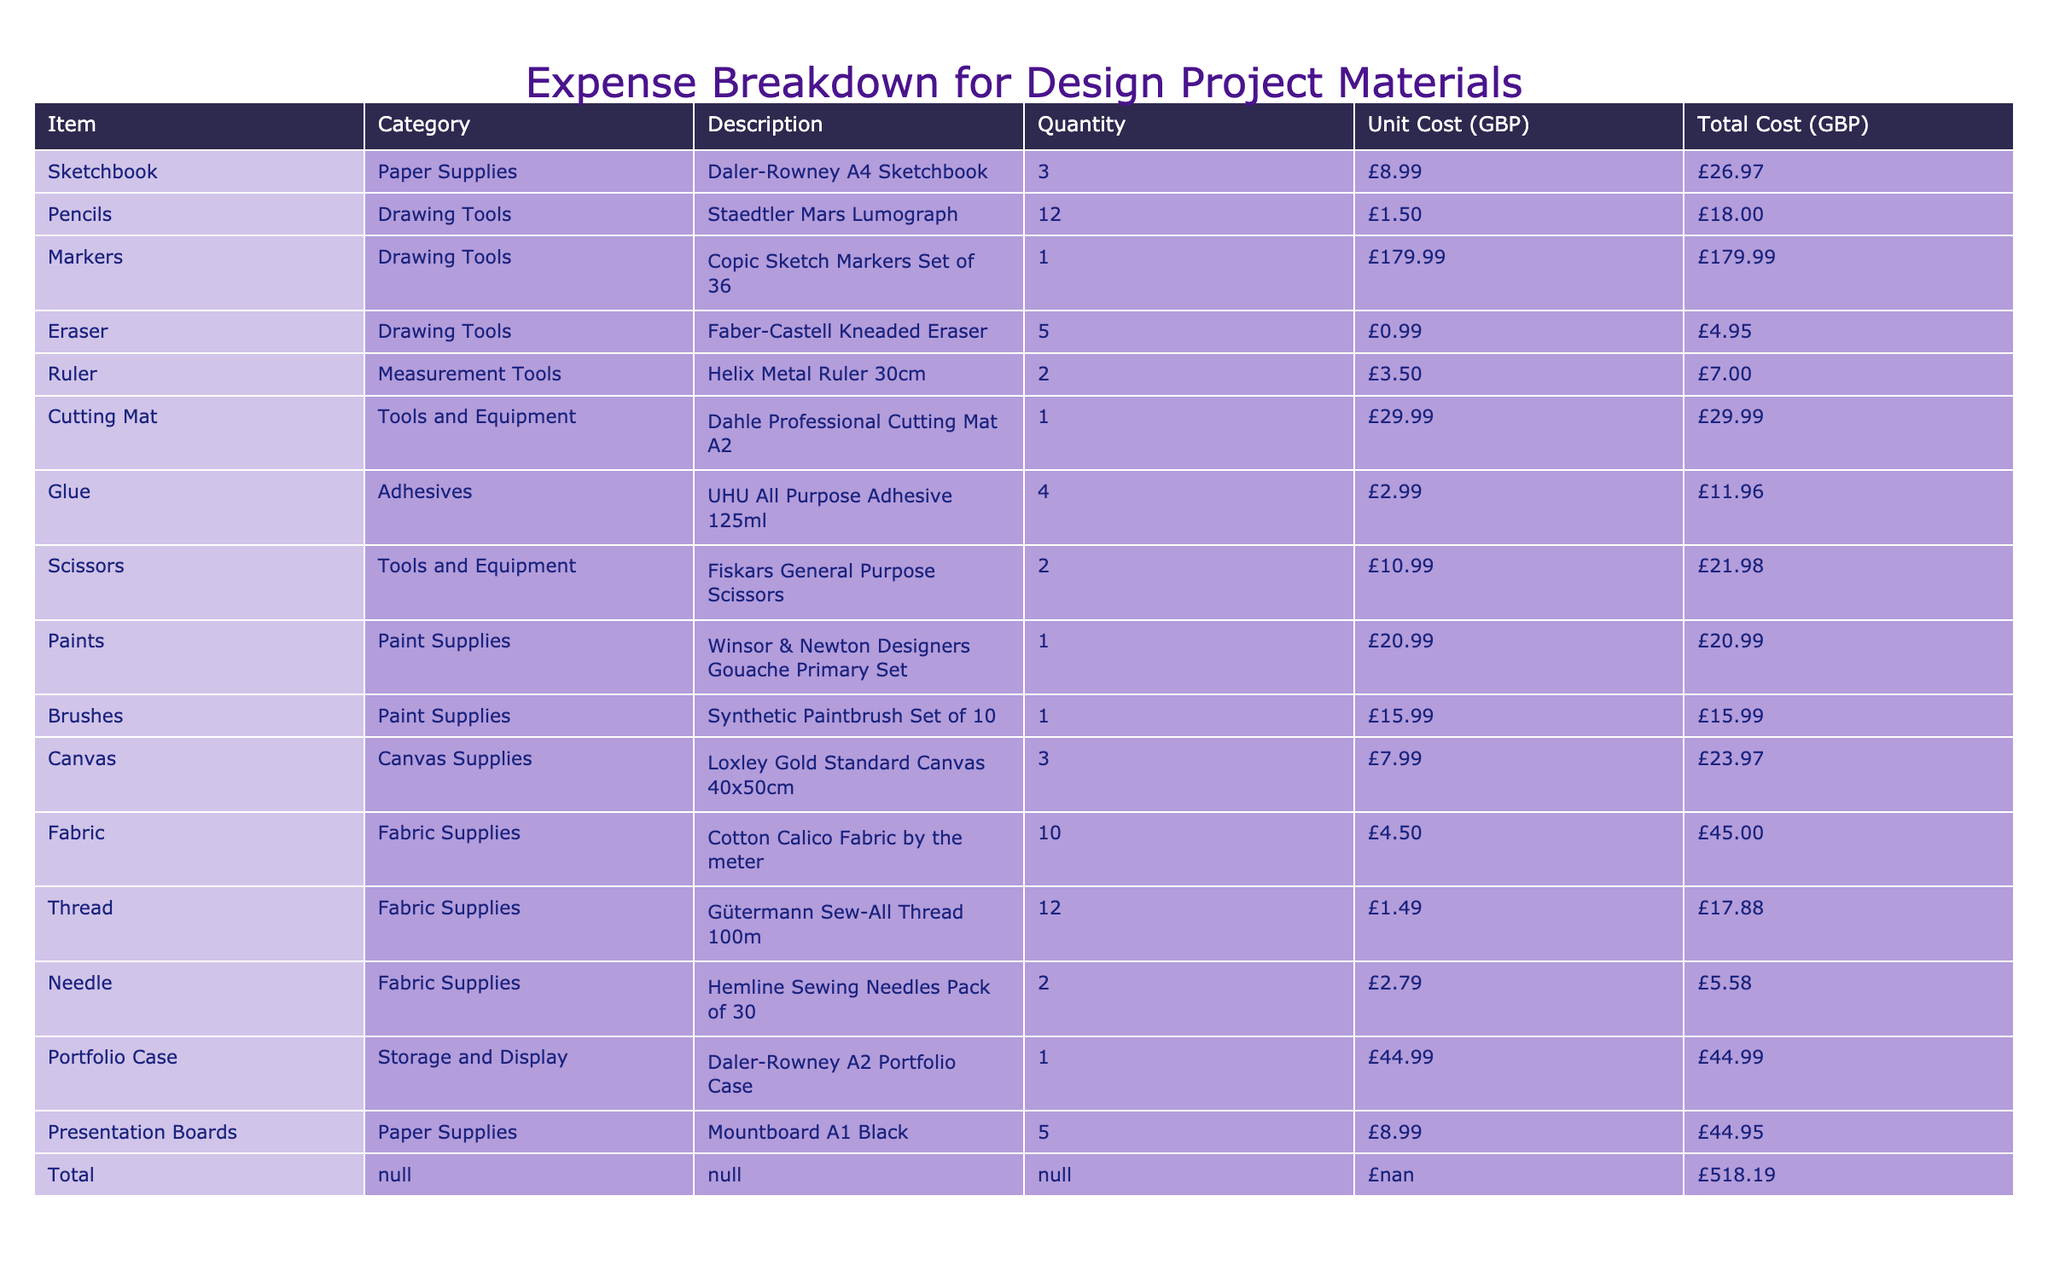What is the total cost of the materials listed? The total cost is provided as a final figure in the table under the "Total" row, which is £518.19.
Answer: £518.19 Which item has the highest total cost? By comparing the "Total Cost (GBP)" for each item, the "Copic Sketch Markers Set of 36" has the highest total cost of £179.99.
Answer: £179.99 How many types of drawing tools are listed in the table? The drawing tools listed include "Pencils," "Markers," and "Eraser," which totals to three types.
Answer: 3 What is the average unit cost of all the fabric supplies? The unit costs for fabric supplies are £4.50, £1.49, and £2.79. Their sum is £4.50 + £1.49 + £2.79 = £8.78, and dividing by the 3 items gives an average of £8.78 / 3 = £2.93.
Answer: £2.93 Is there any item listed under "Measurement Tools"? Yes, there is an item listed under "Measurement Tools," which is "Helix Metal Ruler 30cm."
Answer: Yes What is the total cost for paint supplies? The total cost for paint supplies includes £20.99 for "Winsor & Newton Designers Gouache Primary Set" and £15.99 for "Synthetic Paintbrush Set of 10," summing these gives £20.99 + £15.99 = £36.98.
Answer: £36.98 How much did you spend on paper supplies? The paper supplies are "Daler-Rowney A4 Sketchbook" for £26.97 and "Mountboard A1 Black" for £44.95, totaling £26.97 + £44.95 = £71.92.
Answer: £71.92 Which category has the highest total cost for its items? Reviewing all items by category, "Drawing Tools" has the highest total cost: £18.00 (Pencils) + £179.99 (Markers) + £4.95 (Eraser) = £202.94.
Answer: Drawing Tools 